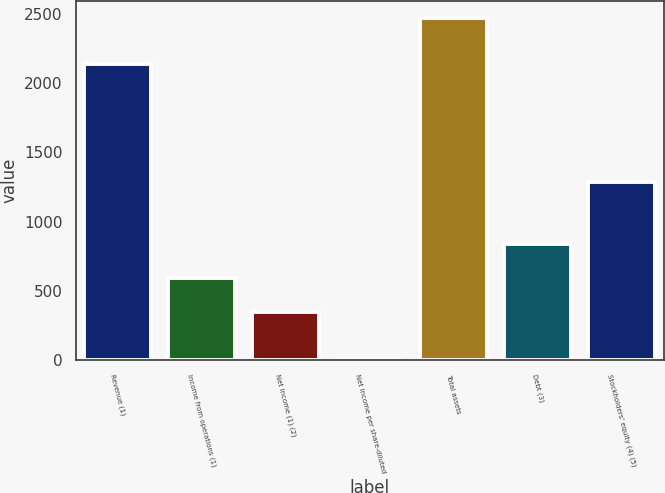<chart> <loc_0><loc_0><loc_500><loc_500><bar_chart><fcel>Revenue (1)<fcel>Income from operations (1)<fcel>Net income (1) (2)<fcel>Net income per share-diluted<fcel>Total assets<fcel>Debt (3)<fcel>Stockholders' equity (4) (5)<nl><fcel>2138<fcel>592.55<fcel>345.8<fcel>1.23<fcel>2468.7<fcel>839.3<fcel>1288.4<nl></chart> 